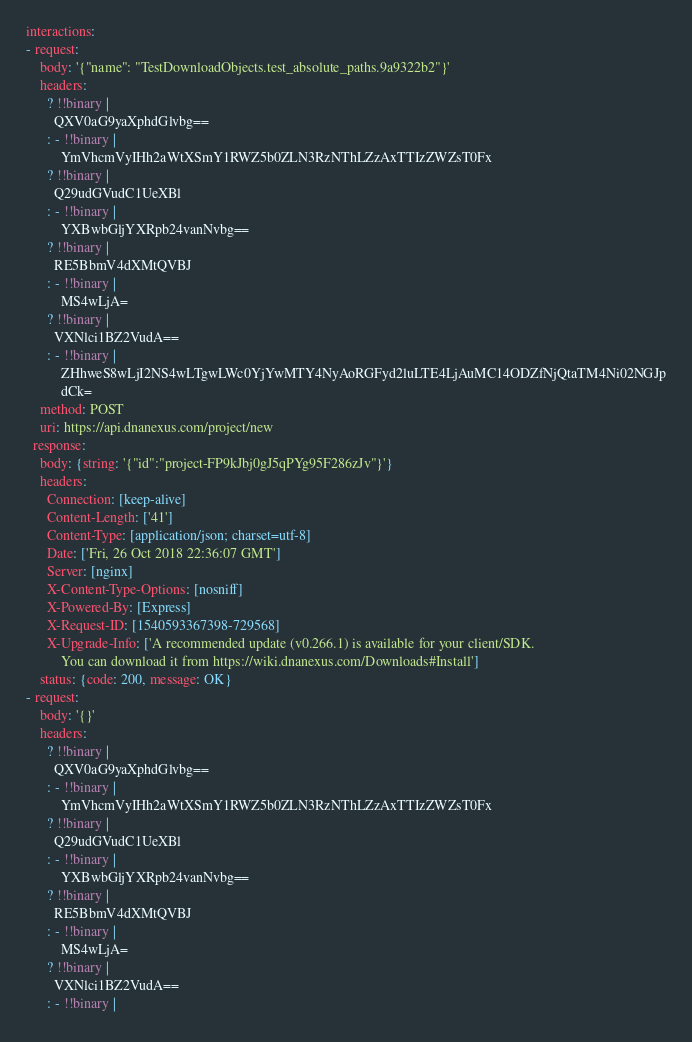<code> <loc_0><loc_0><loc_500><loc_500><_YAML_>interactions:
- request:
    body: '{"name": "TestDownloadObjects.test_absolute_paths.9a9322b2"}'
    headers:
      ? !!binary |
        QXV0aG9yaXphdGlvbg==
      : - !!binary |
          YmVhcmVyIHh2aWtXSmY1RWZ5b0ZLN3RzNThLZzAxTTIzZWZsT0Fx
      ? !!binary |
        Q29udGVudC1UeXBl
      : - !!binary |
          YXBwbGljYXRpb24vanNvbg==
      ? !!binary |
        RE5BbmV4dXMtQVBJ
      : - !!binary |
          MS4wLjA=
      ? !!binary |
        VXNlci1BZ2VudA==
      : - !!binary |
          ZHhweS8wLjI2NS4wLTgwLWc0YjYwMTY4NyAoRGFyd2luLTE4LjAuMC14ODZfNjQtaTM4Ni02NGJp
          dCk=
    method: POST
    uri: https://api.dnanexus.com/project/new
  response:
    body: {string: '{"id":"project-FP9kJbj0gJ5qPYg95F286zJv"}'}
    headers:
      Connection: [keep-alive]
      Content-Length: ['41']
      Content-Type: [application/json; charset=utf-8]
      Date: ['Fri, 26 Oct 2018 22:36:07 GMT']
      Server: [nginx]
      X-Content-Type-Options: [nosniff]
      X-Powered-By: [Express]
      X-Request-ID: [1540593367398-729568]
      X-Upgrade-Info: ['A recommended update (v0.266.1) is available for your client/SDK.
          You can download it from https://wiki.dnanexus.com/Downloads#Install']
    status: {code: 200, message: OK}
- request:
    body: '{}'
    headers:
      ? !!binary |
        QXV0aG9yaXphdGlvbg==
      : - !!binary |
          YmVhcmVyIHh2aWtXSmY1RWZ5b0ZLN3RzNThLZzAxTTIzZWZsT0Fx
      ? !!binary |
        Q29udGVudC1UeXBl
      : - !!binary |
          YXBwbGljYXRpb24vanNvbg==
      ? !!binary |
        RE5BbmV4dXMtQVBJ
      : - !!binary |
          MS4wLjA=
      ? !!binary |
        VXNlci1BZ2VudA==
      : - !!binary |</code> 